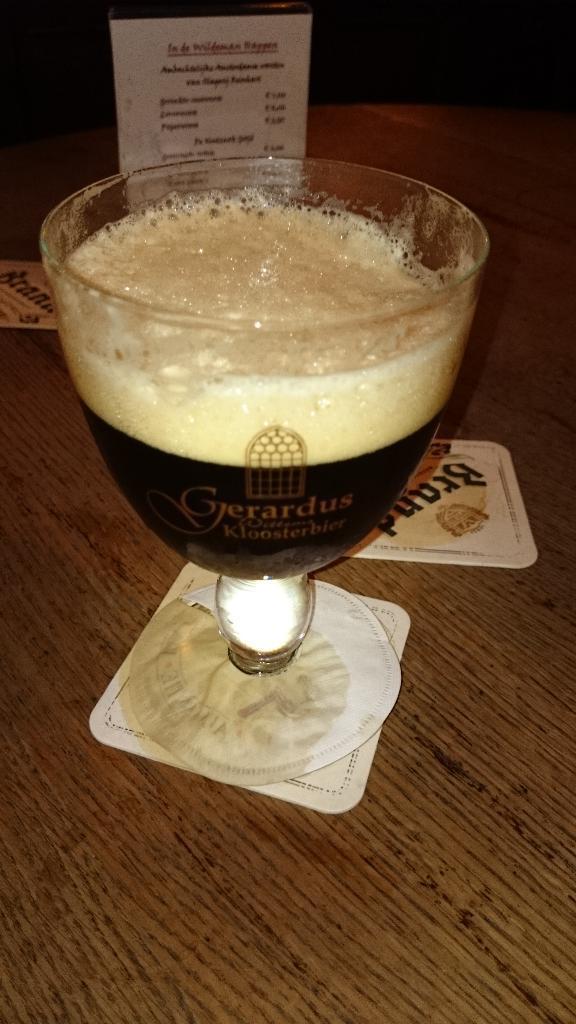Describe this image in one or two sentences. This image consists of a glass in which there is a drink. At the bottom, there is a table. In the background, we can see a card. 